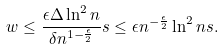Convert formula to latex. <formula><loc_0><loc_0><loc_500><loc_500>w \leq \frac { \epsilon \Delta \ln ^ { 2 } n } { \delta n ^ { 1 - \frac { \epsilon } { 2 } } } s \leq \epsilon n ^ { - \frac { \epsilon } { 2 } } \ln ^ { 2 } n s .</formula> 